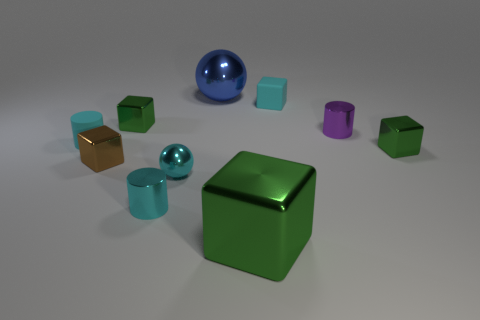Are there any objects in the image that reflect their surroundings? Yes, the two spheres and the various cylinders have reflective surfaces that show their environment.  Can you describe the texture of the objects in the foreground? The objects in the foreground, a large green cube and a smaller blue sphere, have a smooth and glossy surface texture. 